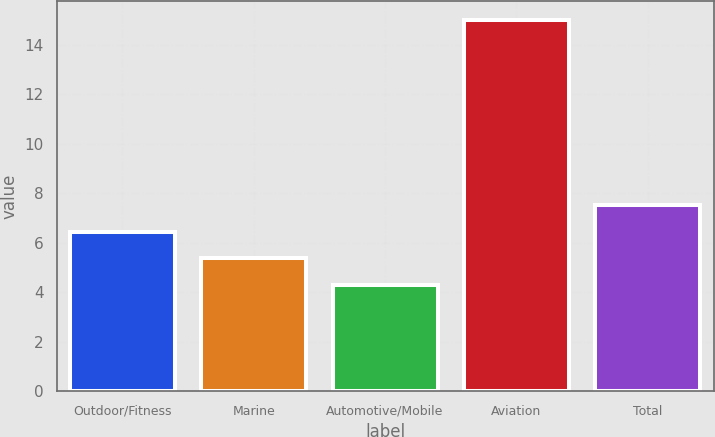<chart> <loc_0><loc_0><loc_500><loc_500><bar_chart><fcel>Outdoor/Fitness<fcel>Marine<fcel>Automotive/Mobile<fcel>Aviation<fcel>Total<nl><fcel>6.44<fcel>5.37<fcel>4.3<fcel>15<fcel>7.51<nl></chart> 